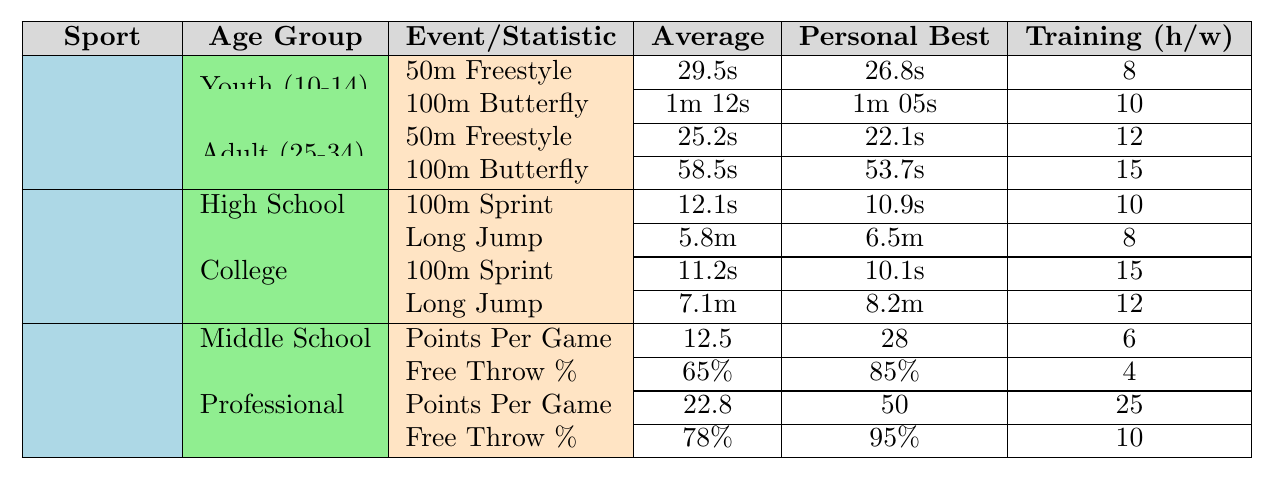What is the average training hours per week for the 50m Freestyle in Youth Swimming? From the table, we can see that the training hours per week for the 50m Freestyle in the Youth group (10-14 years) is 8 hours.
Answer: 8 What is the personal best time for the 100m Butterfly in Adult Swimming? The table shows that the personal best time for the 100m Butterfly in the Adult group (25-34 years) is 53.7 seconds.
Answer: 53.7s Which age group has the highest average score for Points Per Game in Basketball? In the table, the average score for Points Per Game in Middle School is 12.5, while in the Professional group it is 22.8. Therefore, the Professional group has the highest average score.
Answer: Professional (22-35) How much more training hours are required per week for Professionals in Basketball compared to Middle School? The training hours for the Professional group are 25 hours, and for the Middle School group, it is 6 hours. The difference is 25 - 6 = 19 hours.
Answer: 19 hours What is the average time for the 50m Freestyle across all age groups in Swimming? For Youth, the average time is 29.5 seconds, and for Adults, it is 25.2 seconds. To find the average: (29.5 + 25.2) / 2 = 27.35 seconds.
Answer: 27.35s Is the personal best for the Long Jump in the College age group better than that in High School? The table shows that the personal best in High School is 6.5m, while in College, it is 8.2m. Since 8.2m > 6.5m, the Long Jump in College is better.
Answer: Yes What is the total training hours per week for all events under the High School Track and Field category? The training hours for the 100m Sprint is 10 and for the Long Jump is 8. Summing these gives 10 + 8 = 18 hours.
Answer: 18 hours Which sport has the lowest average score for Free Throw Percentage in its age group? The Free Throw Percentage in Middle School is 65%, and for Professionals, it is 78%. Since 65% < 78%, Basketball has the lowest average score for Free Throw Percentage in the Middle School age group.
Answer: Basketball What is the average personal best for the 100m Sprint across both age groups in Track and Field? From High School, the personal best is 10.9 seconds and from College, it is 10.1 seconds. To calculate the average: (10.9 + 10.1) / 2 = 10.5 seconds.
Answer: 10.5s How does the average time for 100m Butterfly in Youth compare to Adults? The average time for Youth is 1m 12s (or 72 seconds) and for Adults it is 58.5 seconds. Since 72s > 58.5s, Youth takes longer on average than Adults.
Answer: Youth takes longer 